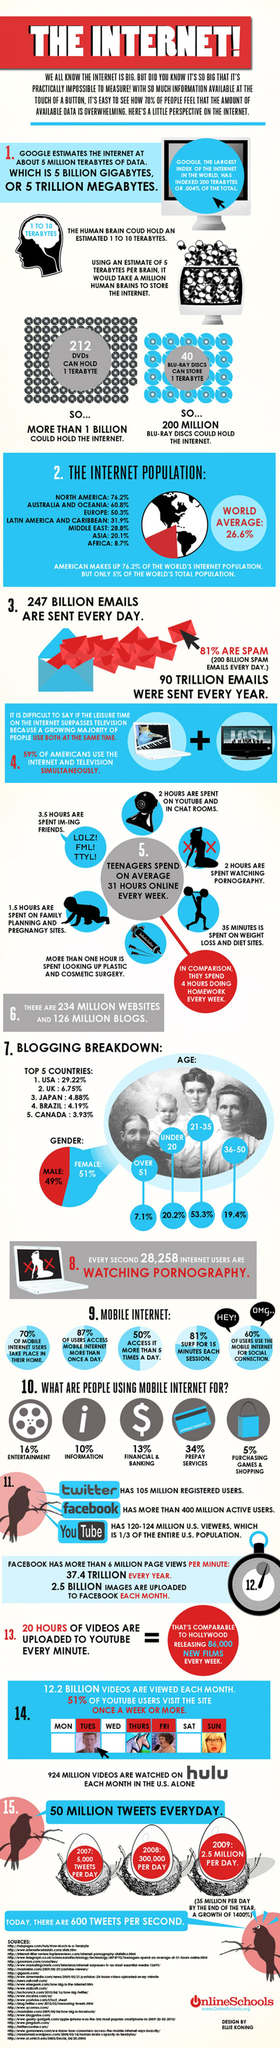Indicate a few pertinent items in this graphic. In 2009, approximately 2.5 million tweets were made per day. According to a survey, 49% of bloggers are male. In Europe, approximately 50.3% of the internet population can be found. In 2008, approximately 300,000 tweets were made per day. According to a study, 60% of users use the mobile internet for social connection. 